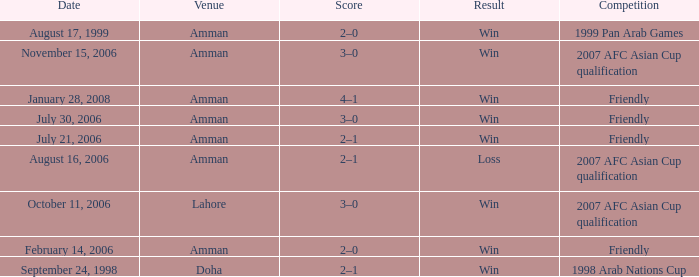What was the score of the friendly match at Amman on February 14, 2006? 2–0. 